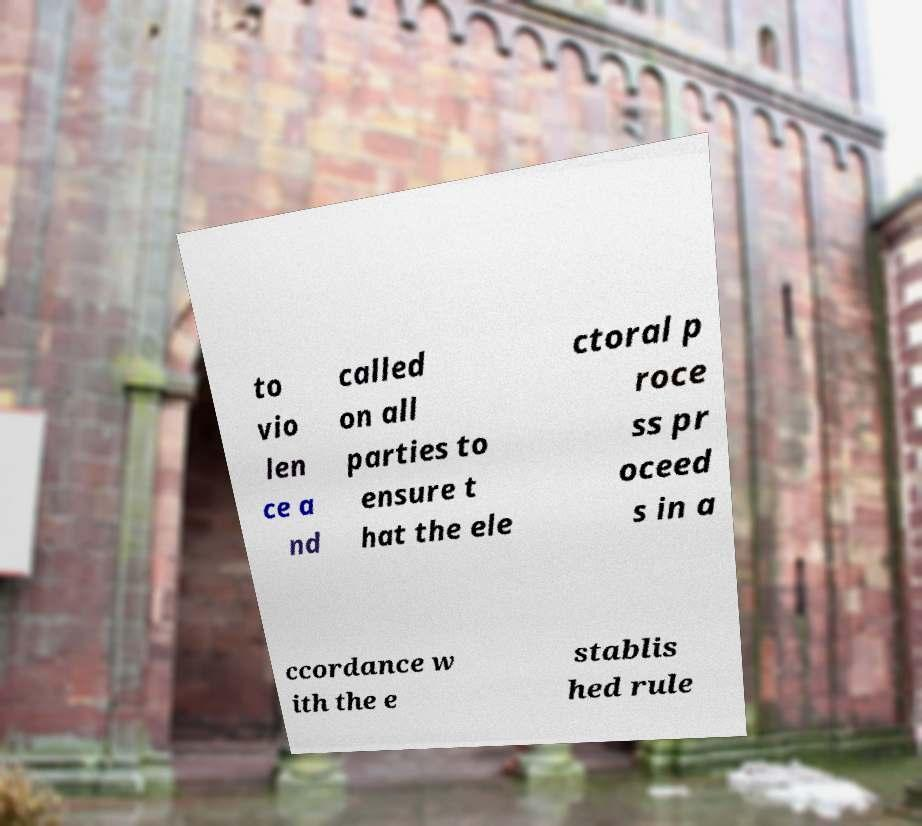For documentation purposes, I need the text within this image transcribed. Could you provide that? to vio len ce a nd called on all parties to ensure t hat the ele ctoral p roce ss pr oceed s in a ccordance w ith the e stablis hed rule 